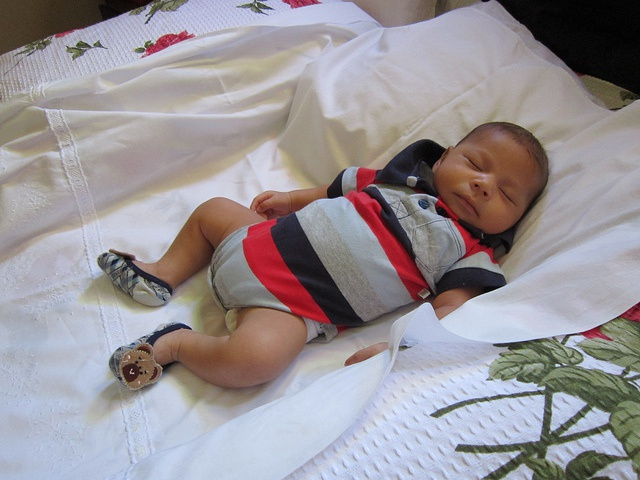Describe the objects in this image and their specific colors. I can see bed in darkgray, lavender, gray, and black tones and people in black, gray, and darkgray tones in this image. 